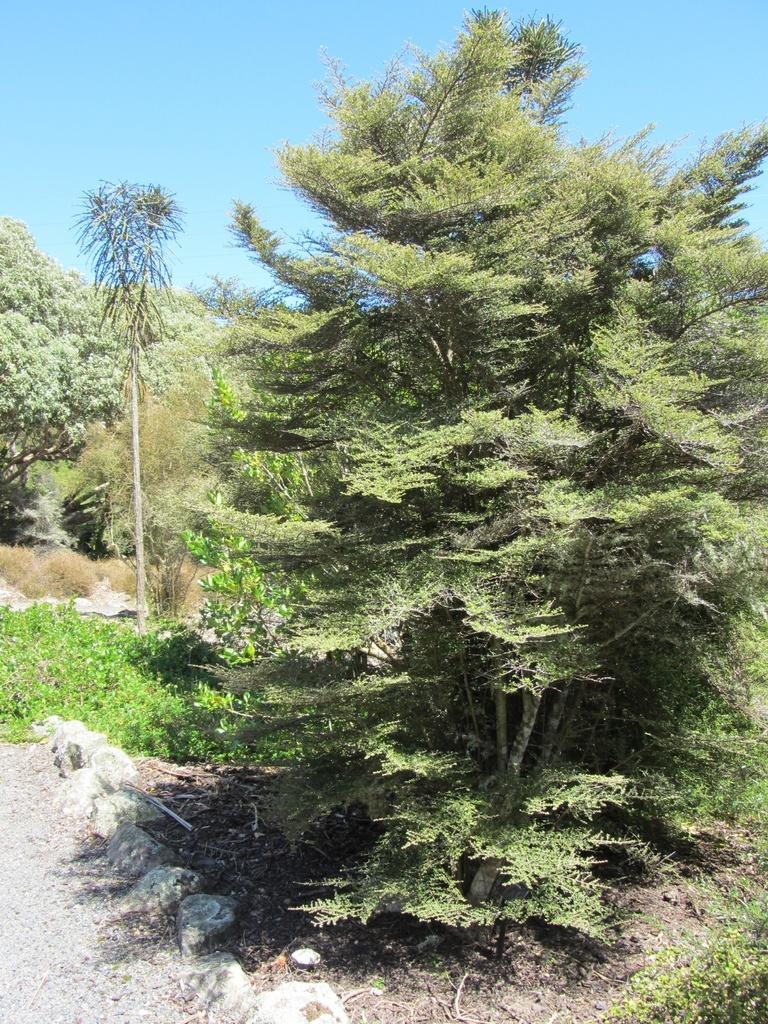What type of vegetation can be seen in the image? There is a lot of greenery in the image, including grass, plants, and tall trees. Can you describe the ground on the left side of the image? There is a cement land on the left side of the image. How does the fan contribute to the experience of the image? There is no fan present in the image, so it cannot contribute to the experience. 